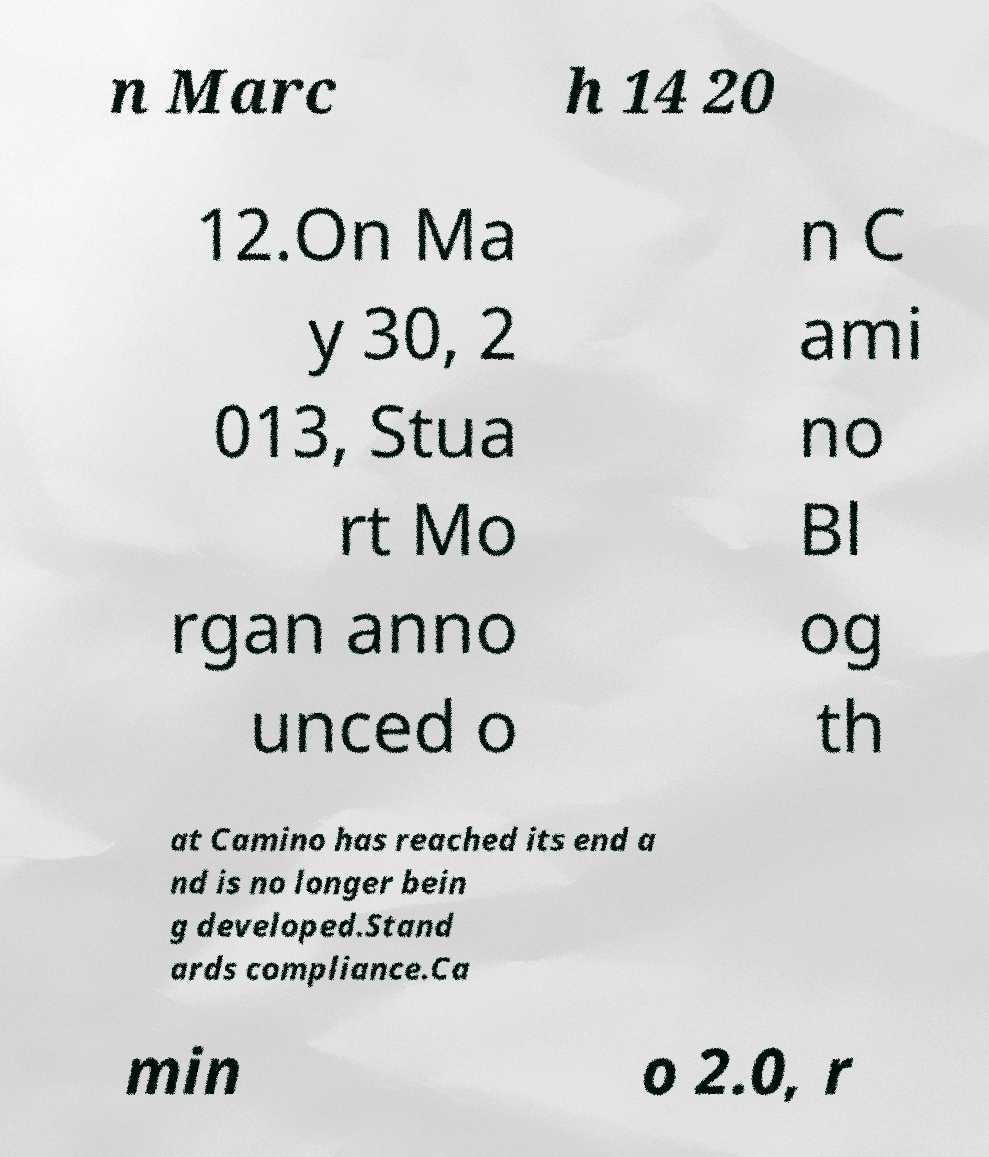What messages or text are displayed in this image? I need them in a readable, typed format. n Marc h 14 20 12.On Ma y 30, 2 013, Stua rt Mo rgan anno unced o n C ami no Bl og th at Camino has reached its end a nd is no longer bein g developed.Stand ards compliance.Ca min o 2.0, r 